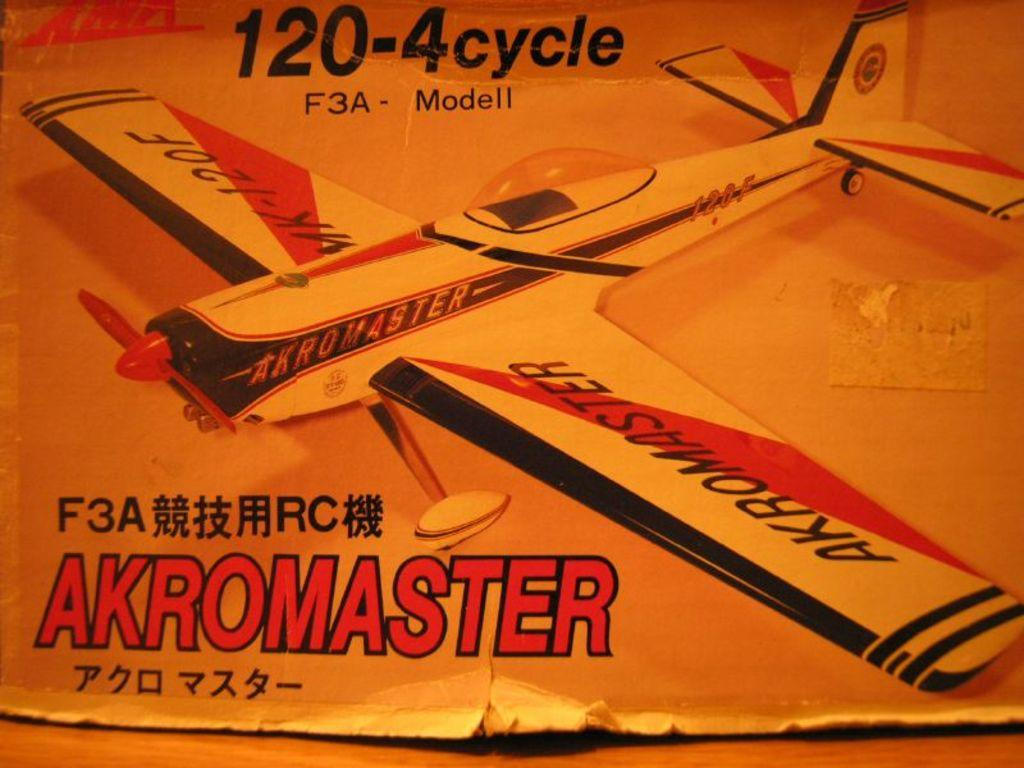Provide a one-sentence caption for the provided image. A model plane with Akromaster on one of its wings. 